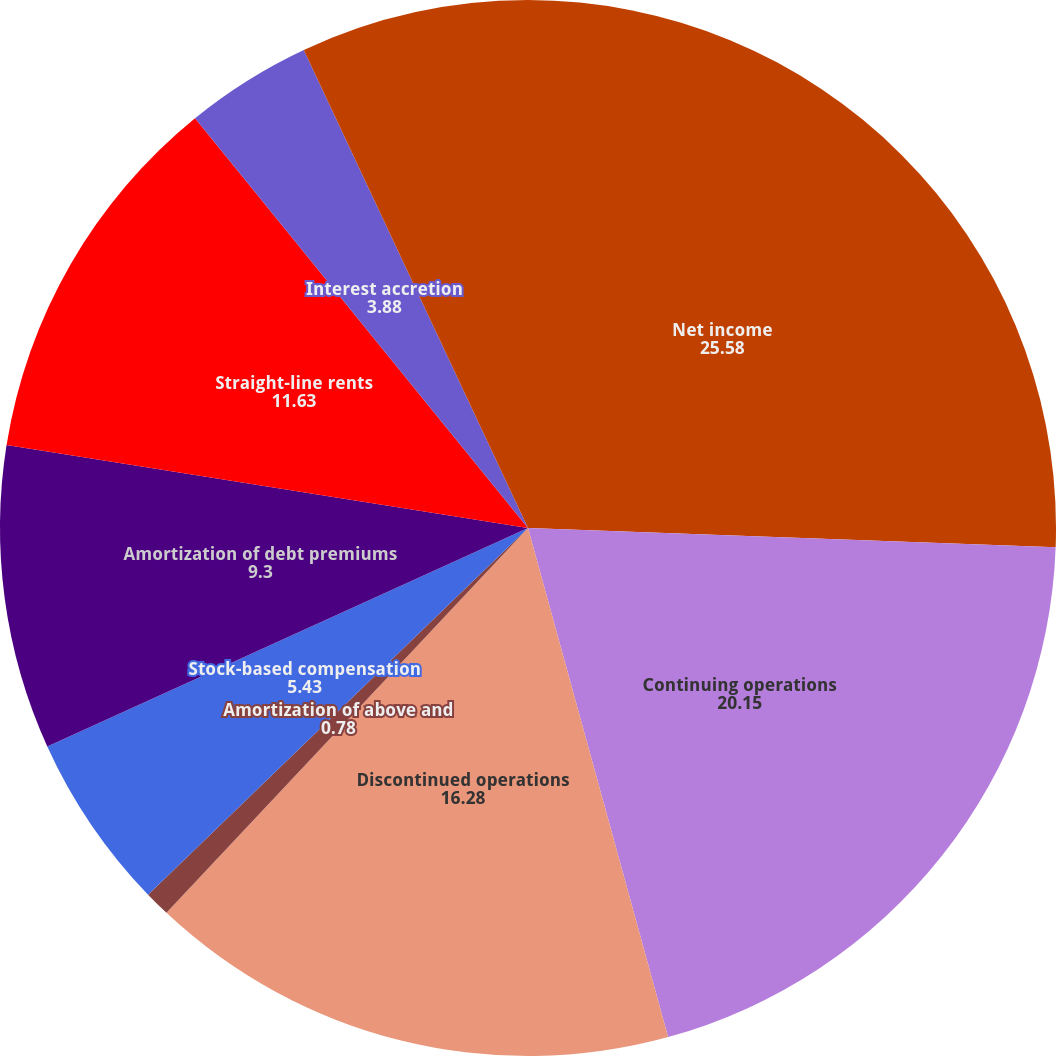Convert chart. <chart><loc_0><loc_0><loc_500><loc_500><pie_chart><fcel>Net income<fcel>Continuing operations<fcel>Discontinued operations<fcel>Amortization of above and<fcel>Stock-based compensation<fcel>Amortization of debt premiums<fcel>Straight-line rents<fcel>Interest accretion<fcel>Deferred rental revenue<fcel>Equity income from<nl><fcel>25.58%<fcel>20.15%<fcel>16.28%<fcel>0.78%<fcel>5.43%<fcel>9.3%<fcel>11.63%<fcel>3.88%<fcel>0.0%<fcel>6.98%<nl></chart> 